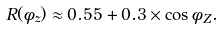Convert formula to latex. <formula><loc_0><loc_0><loc_500><loc_500>R ( \phi _ { z } ) \approx 0 . 5 5 + 0 . 3 \times \cos \phi _ { Z } .</formula> 